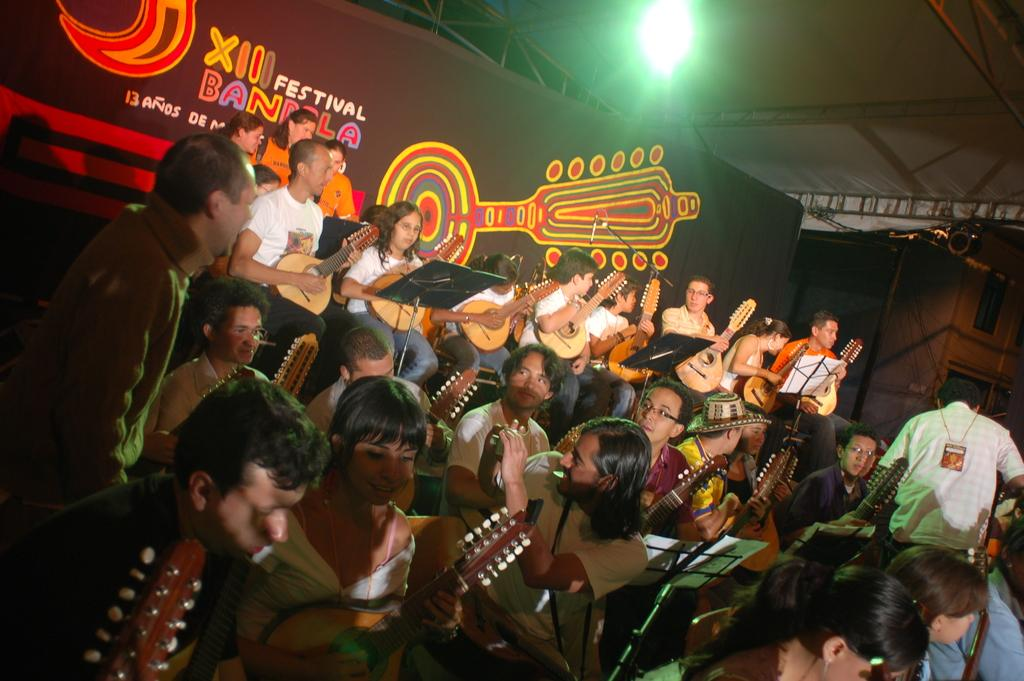What are the people in the image doing? The people in the image are standing and sitting while holding musical instruments. What can be seen hanging or displayed in the image? There is a banner visible in the image. What is the structure above the people in the image? There is a roof at the top of the image. What can be seen coming from the top of the image? There is light visible at the top of the image. What type of quilt is being used as a stage prop in the image? There is no quilt present in the image. How many beds can be seen in the image? There are no beds visible in the image. 